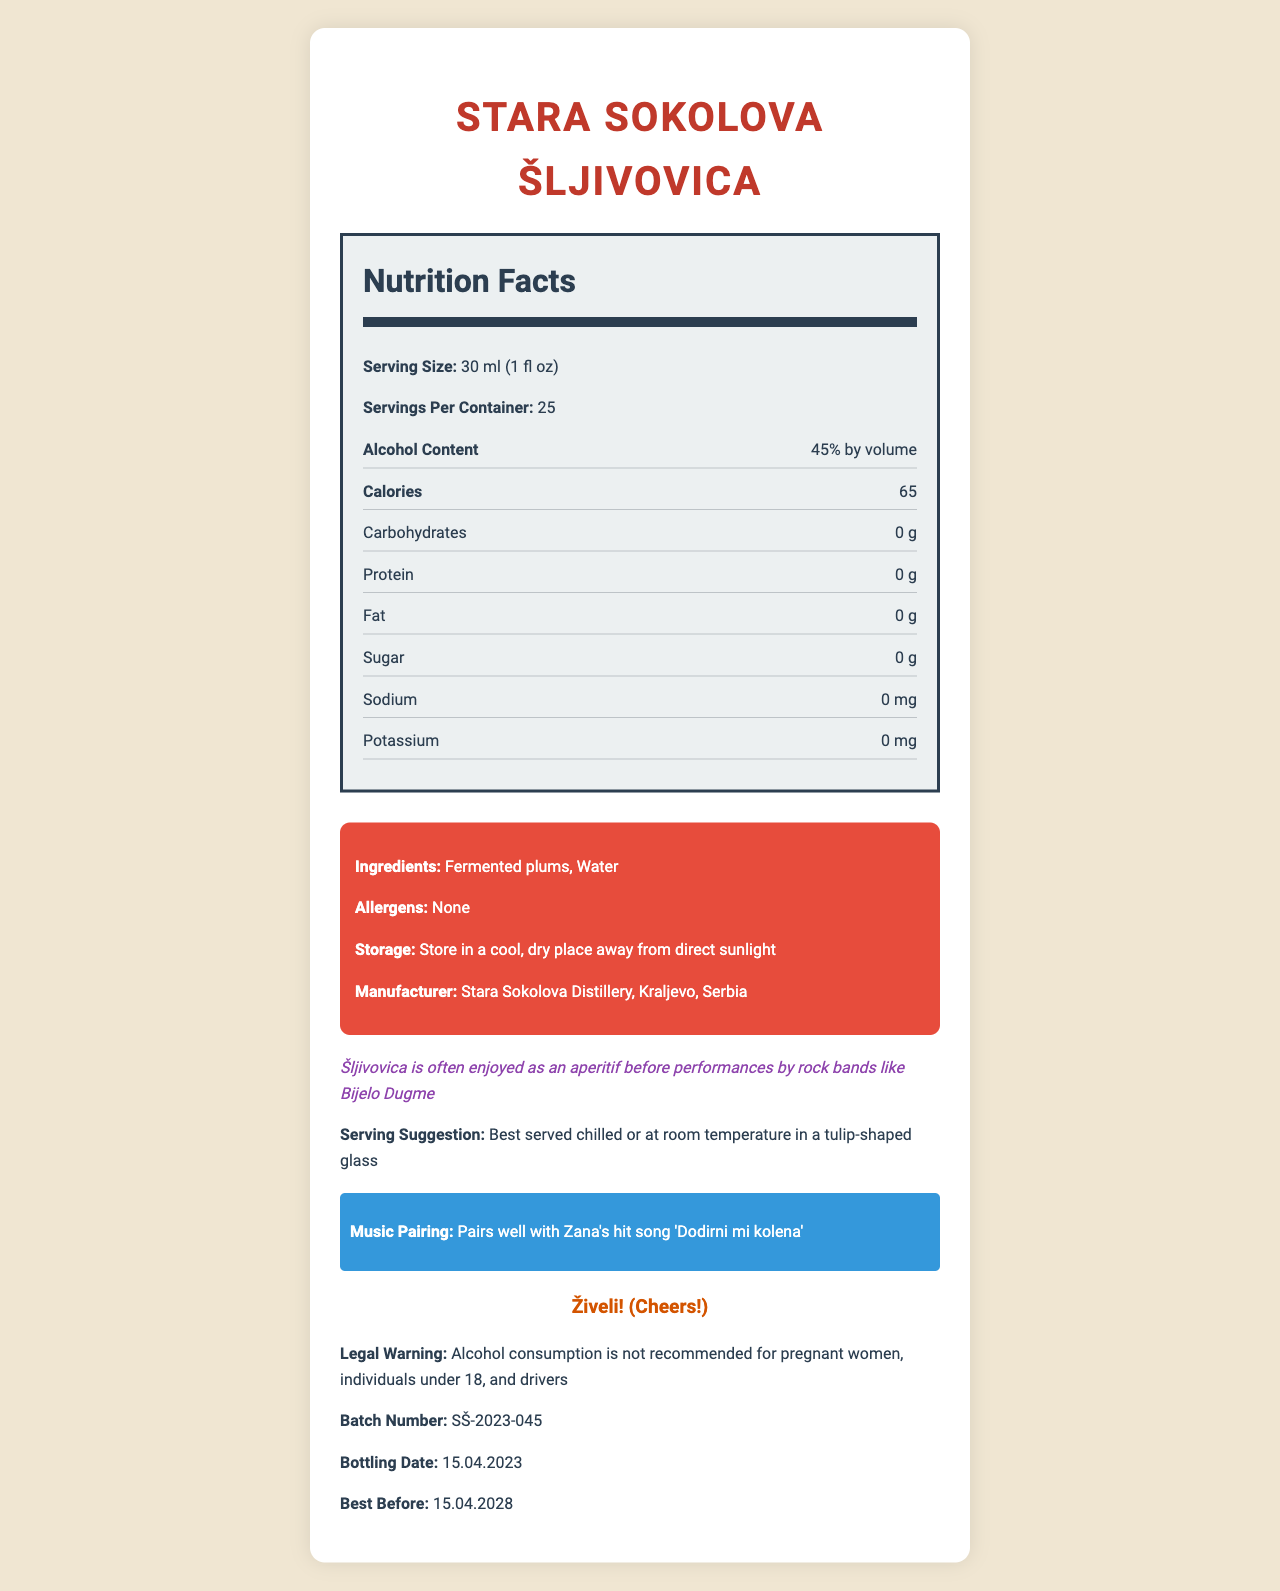what is the serving size of Stara Sokolova Šljivovica? The serving size is listed as "30 ml (1 fl oz)" in the document.
Answer: 30 ml (1 fl oz) how many servings per container are there? The document specifies "Servings Per Container: 25".
Answer: 25 what is the alcohol content of this Rakija? The alcohol content is stated as "45% by volume".
Answer: 45% by volume how many calories are in each serving? Each serving contains "65 calories" as per the nutrition facts.
Answer: 65 what are the ingredients of Stara Sokolova Šljivovica? The ingredients listed are "Fermented plums" and "Water".
Answer: Fermented plums, Water which band is mentioned in the fun fact section? The fun fact states that Šljivovica is often enjoyed before performances by Bijelo Dugme.
Answer: Bijelo Dugme which song by Zana is recommended for pairing? A. "Majstor za poljupce" B. "Dodirni mi kolena" C. "Zbog tebe" The document suggests pairing the drink with "Dodirni mi kolena" by Zana.
Answer: B how should Stara Sokolova Šljivovica be served? The serving suggestion is "Best served chilled or at room temperature in a tulip-shaped glass".
Answer: Best served chilled or at room temperature in a tulip-shaped glass how many grams of carbohydrates does it contain? The nutrition facts state that carbohydrates are "0 g".
Answer: 0 g what should be said when toasting with this Rakija? The traditional toast provided is "Živeli! (Cheers!)".
Answer: Živeli! does Stara Sokolova Šljivovica contain any allergens? The document specifies "Allergens: None".
Answer: No what is the bottling date of this Rakija? The bottling date listed is "15.04.2023".
Answer: 15.04.2023 what is the calorie content from alcohol alone? The document states "Calories from alcohol: 65".
Answer: 65 calories which of the following is incorrect based on the nutrition facts? A. It contains 0 g of protein B. It has 10 mg of sodium C. It contains 65 calories It contains 0 mg of sodium as per the nutrition facts.
Answer: B for how long can Stara Sokolova Šljivovica be stored from the bottling date? The best before date is "15.04.2028", which is 5 years from the bottling date.
Answer: 5 years how much sugar is in a serving of Stara Sokolova Šljivovica? The document lists sugar content as "0 g".
Answer: 0 g is there any fat in this Rakija? The nutrition facts state that fat content is "0 g".
Answer: No can you determine the price of Stara Sokolova Šljivovica from this document? The document does not provide any details about the price.
Answer: Not enough information summarize the main information provided in the nutrition facts label for Stara Sokolova Šljivovica. The main information summarized includes product details like serving size, alcohol content, calorie content, ingredients, storage instructions, manufacturer information, and additional fun facts and recommendations.
Answer: Stara Sokolova Šljivovica is a Serbian brandy with an alcohol content of 45% by volume. The serving size is 30 ml (1 fl oz), with 25 servings per container. Each serving contains 65 calories, and the drink contains no carbohydrates, protein, fat, sugar, sodium, or potassium. The ingredients include fermented plums and water. The drink has no allergens and should be stored in a cool, dry place away from direct sunlight. It is manufactured by Stara Sokolova Distillery in Kraljevo, Serbia. The label includes a fun fact about enjoying Šljivovica before Bijelo Dugme performances, a serving suggestion, a music pairing recommendation with Zana's song "Dodirni mi kolena", a traditional toast, a legal warning about alcohol consumption, and details about the batch number, bottling date, and best before date. 